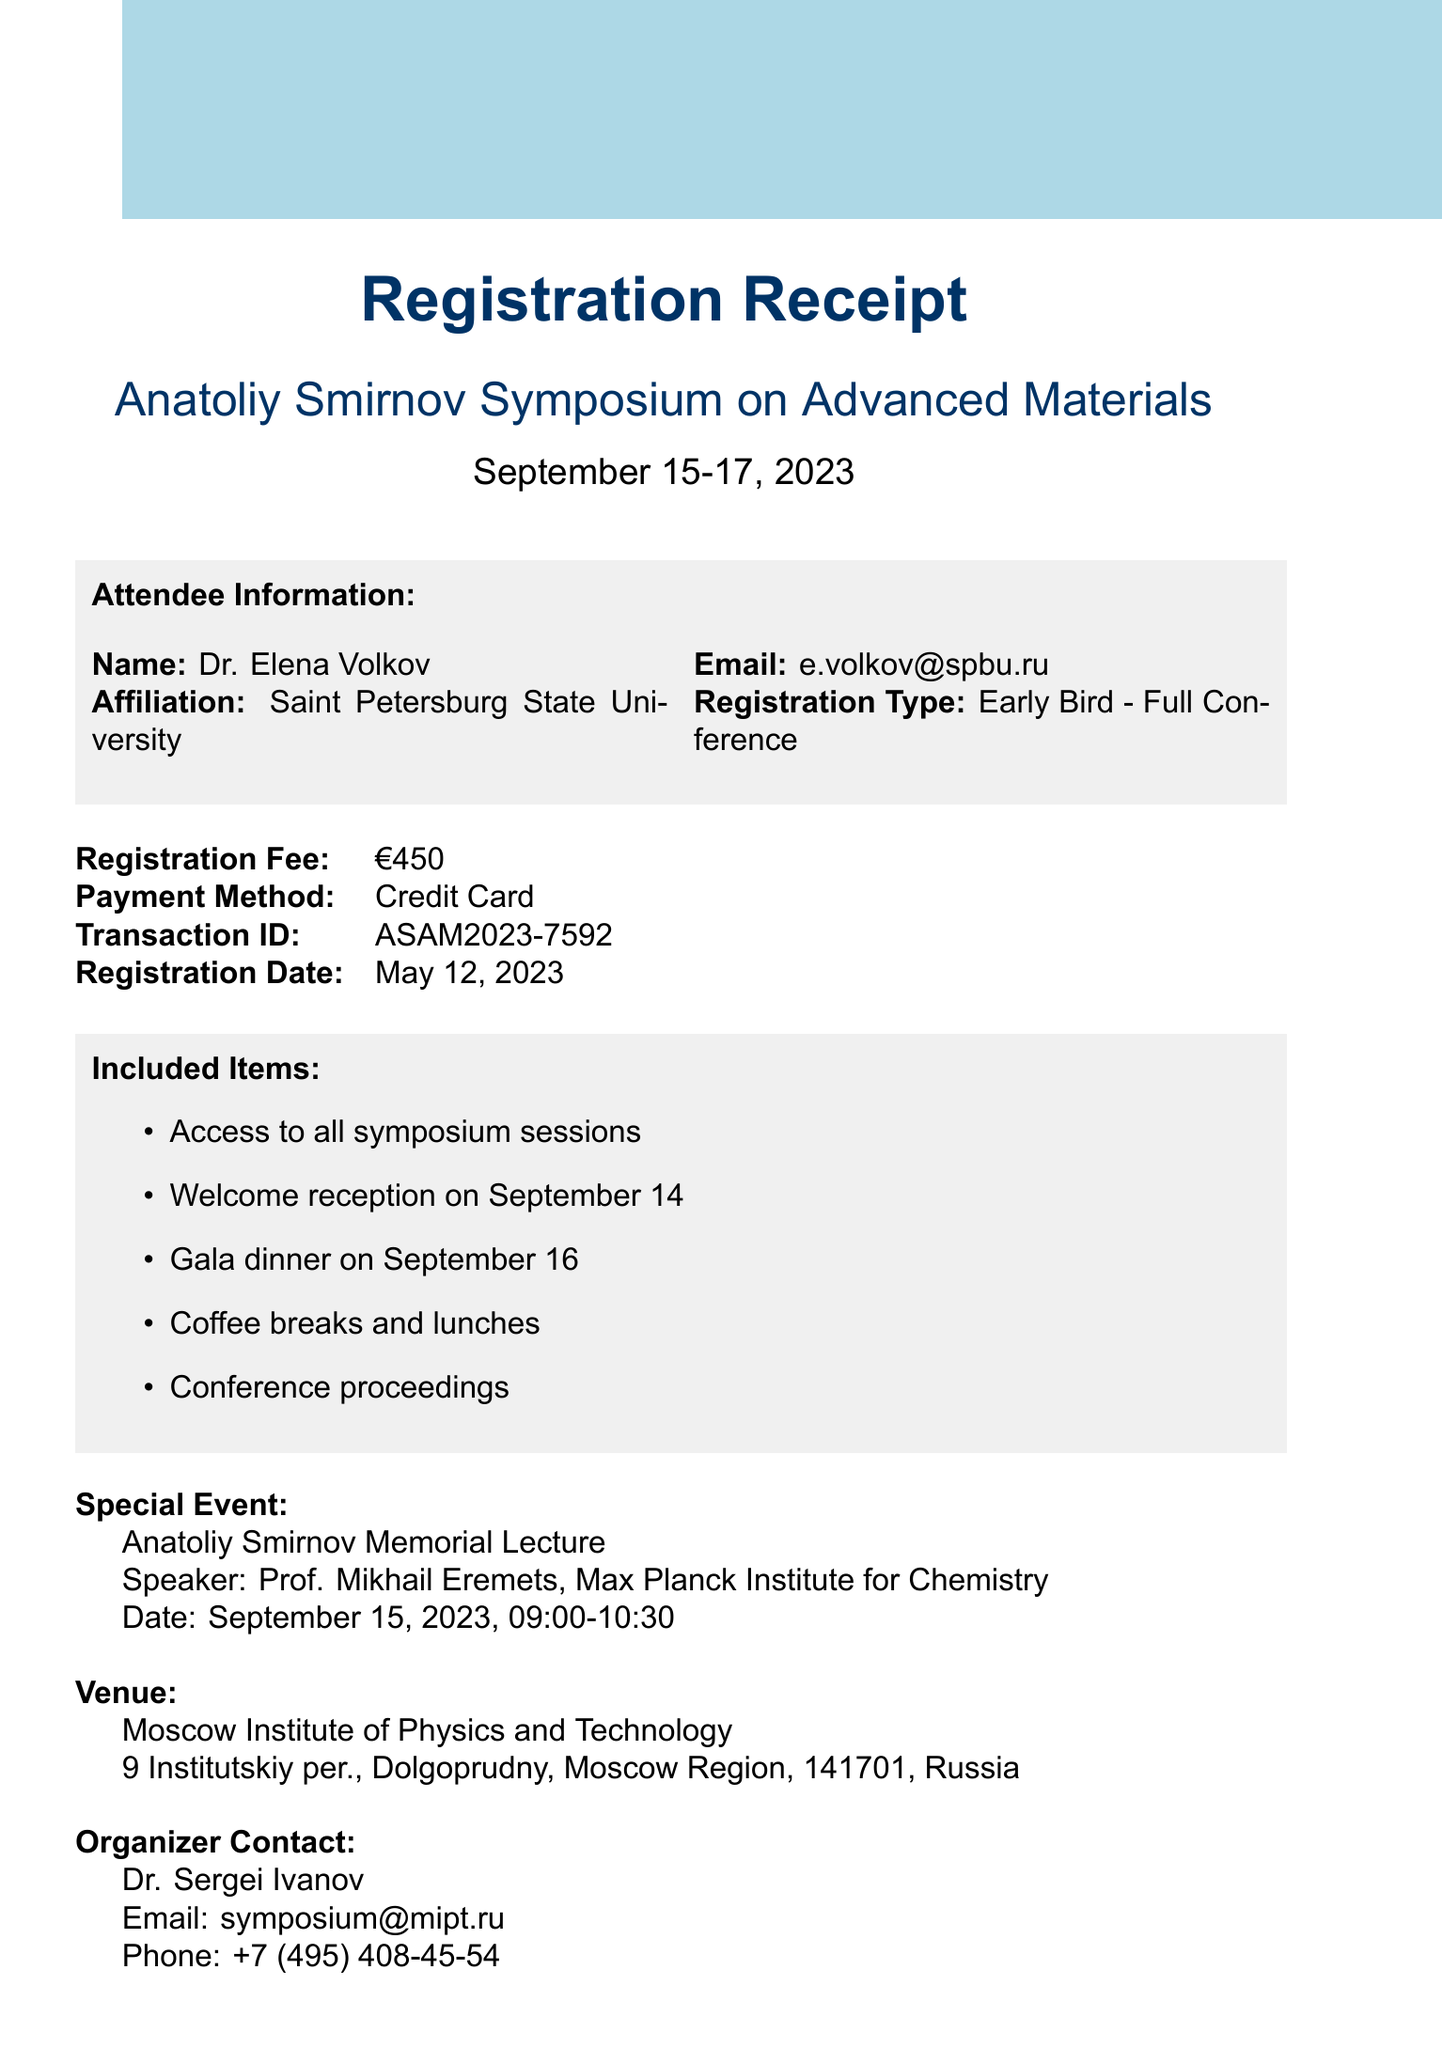What is the name of the symposium? The document states the event name explicitly at the beginning.
Answer: Anatoliy Smirnov Symposium on Advanced Materials When was the registration date? The registration date is explicitly mentioned in the document.
Answer: May 12, 2023 Who is the speaker of the Anatoliy Smirnov Memorial Lecture? The document provides the name of the speaker for the special event section.
Answer: Prof. Mikhail Eremets What is the registration fee? The registration fee is clearly listed in a specific section of the receipt.
Answer: €450 What types of items are included in the registration? The document lists several items included in the registration under the included items section.
Answer: Access to all symposium sessions, Welcome reception, Gala dinner, Coffee breaks and lunches, Conference proceedings Where is the venue located? The venue's address is provided directly under the venue section of the document.
Answer: 9 Institutskiy per., Dolgoprudny, Moscow Region, 141701, Russia What is the transaction ID for the registration? The transaction ID is clearly stated in the registration details.
Answer: ASAM2023-7592 Why is the personal note included in the document? The personal note highlights the significance of the event to the attendee, honoring the contributions of Anatoliy Smirnov.
Answer: To honor Anatoliy Smirnov What is the date of the gala dinner? The gala dinner is mentioned as part of the included items with a specific date.
Answer: September 16 